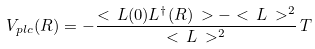Convert formula to latex. <formula><loc_0><loc_0><loc_500><loc_500>V _ { p l c } ( R ) = - \frac { < \, L ( 0 ) L ^ { \dag } ( R ) \, > - < \, L \, > ^ { 2 } } { < \, L \, > ^ { 2 } } \, T</formula> 